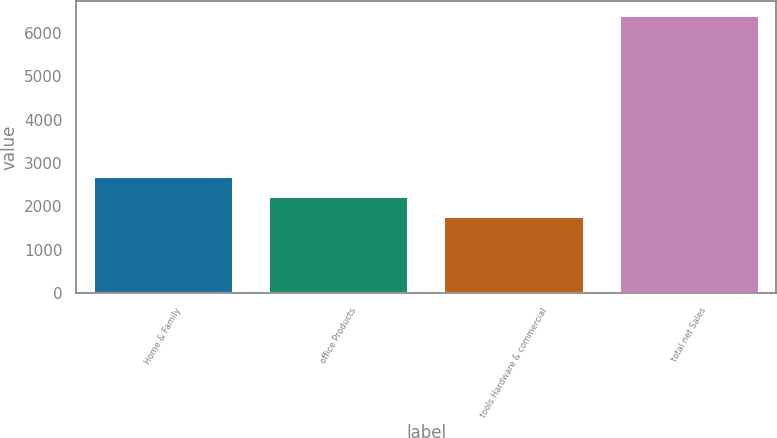Convert chart to OTSL. <chart><loc_0><loc_0><loc_500><loc_500><bar_chart><fcel>Home & Family<fcel>office Products<fcel>tools Hardware & commercial<fcel>total net Sales<nl><fcel>2697.7<fcel>2234<fcel>1770.3<fcel>6407.3<nl></chart> 